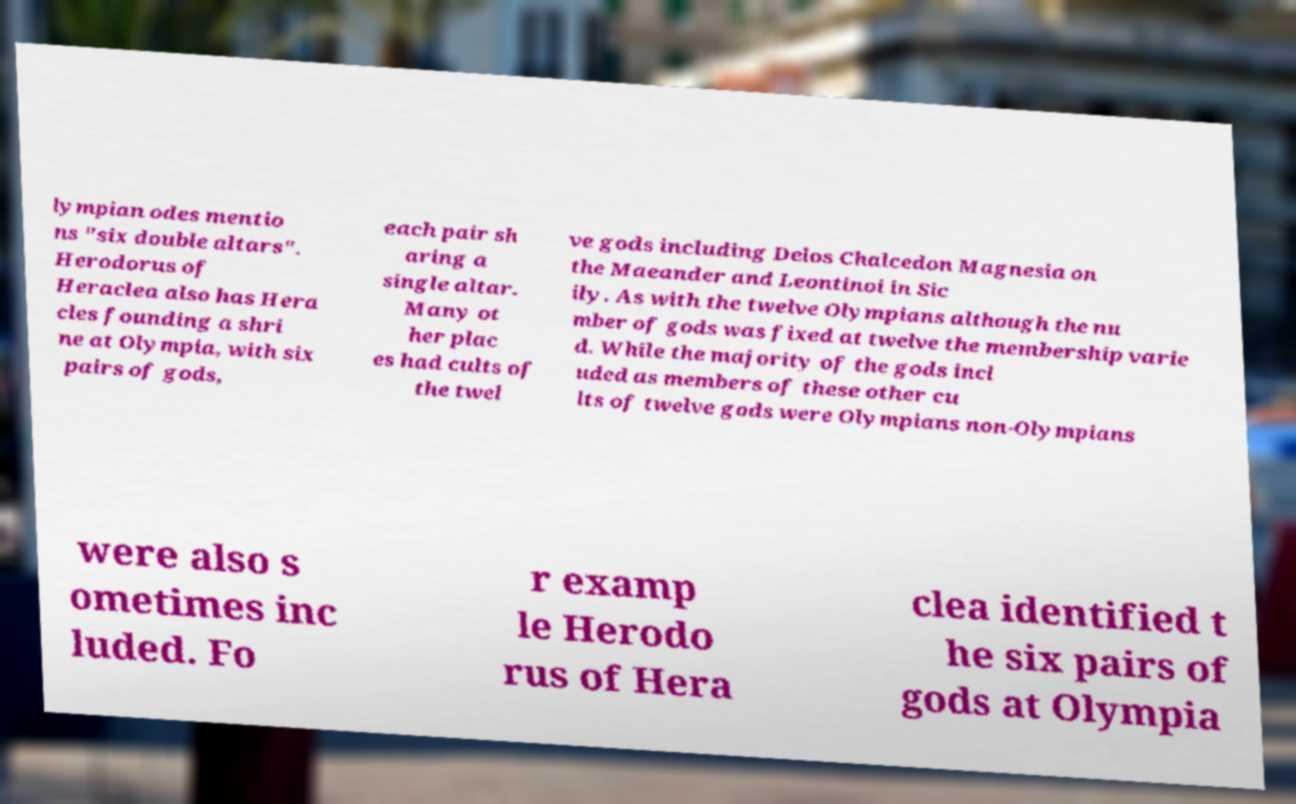There's text embedded in this image that I need extracted. Can you transcribe it verbatim? lympian odes mentio ns "six double altars". Herodorus of Heraclea also has Hera cles founding a shri ne at Olympia, with six pairs of gods, each pair sh aring a single altar. Many ot her plac es had cults of the twel ve gods including Delos Chalcedon Magnesia on the Maeander and Leontinoi in Sic ily. As with the twelve Olympians although the nu mber of gods was fixed at twelve the membership varie d. While the majority of the gods incl uded as members of these other cu lts of twelve gods were Olympians non-Olympians were also s ometimes inc luded. Fo r examp le Herodo rus of Hera clea identified t he six pairs of gods at Olympia 